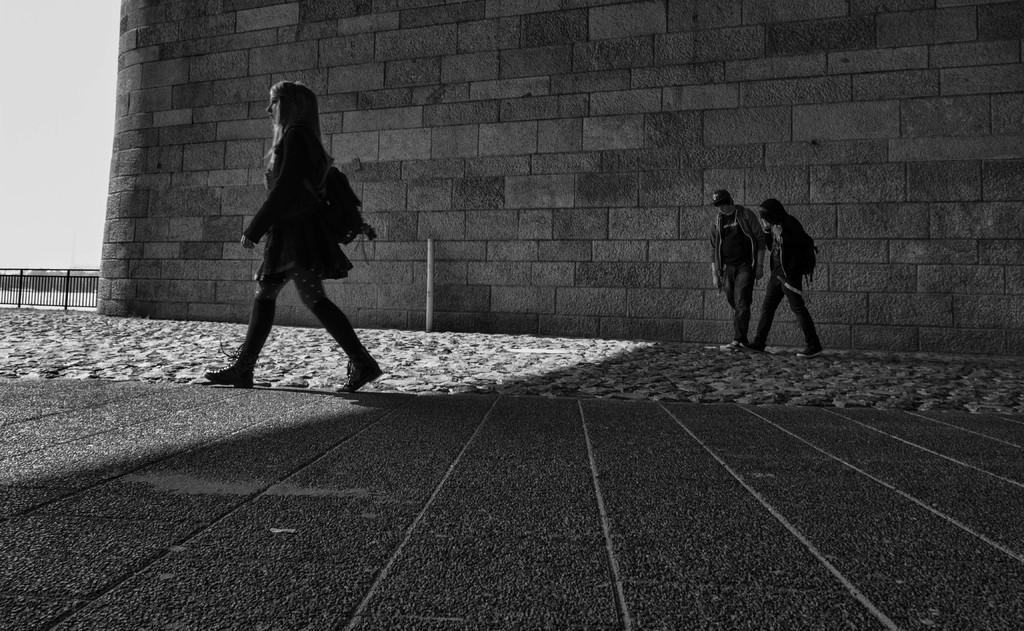Can you describe this image briefly? In this picture, we can see few people, ground, pole, fencing, the wall, and the sky. 